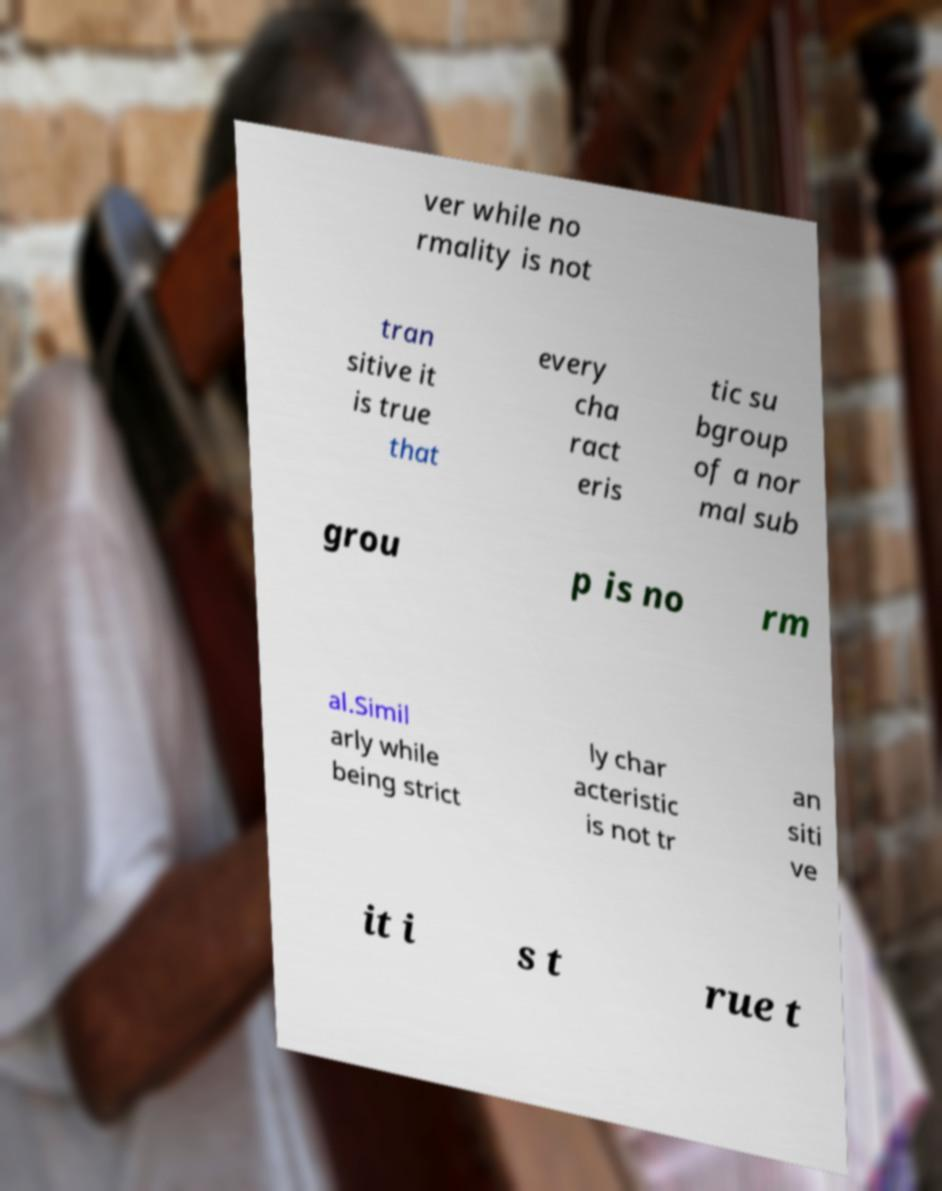Please identify and transcribe the text found in this image. ver while no rmality is not tran sitive it is true that every cha ract eris tic su bgroup of a nor mal sub grou p is no rm al.Simil arly while being strict ly char acteristic is not tr an siti ve it i s t rue t 